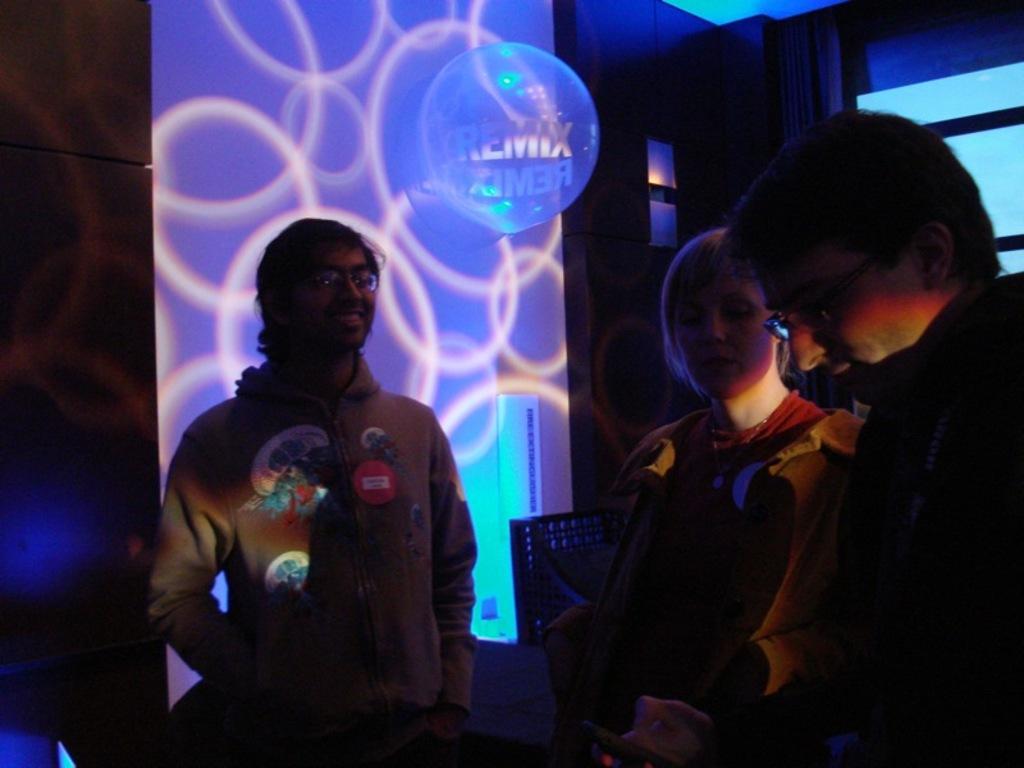Describe this image in one or two sentences. In this image I can see three people with the dresses. In the background I can see the wall and there is a light focused on the wall. 